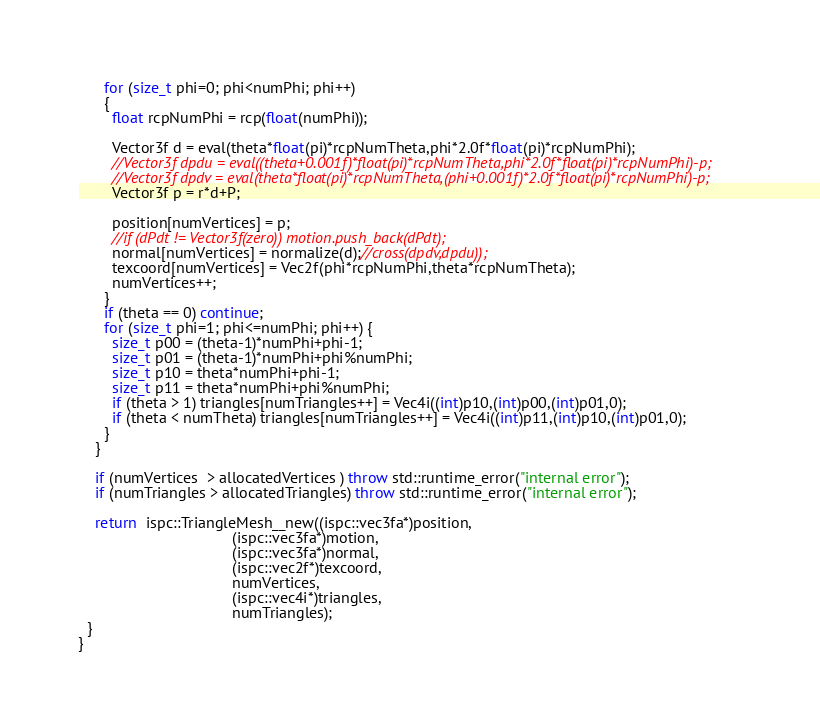Convert code to text. <code><loc_0><loc_0><loc_500><loc_500><_C++_>      for (size_t phi=0; phi<numPhi; phi++)
      {
        float rcpNumPhi = rcp(float(numPhi));
        
        Vector3f d = eval(theta*float(pi)*rcpNumTheta,phi*2.0f*float(pi)*rcpNumPhi);
        //Vector3f dpdu = eval((theta+0.001f)*float(pi)*rcpNumTheta,phi*2.0f*float(pi)*rcpNumPhi)-p;
        //Vector3f dpdv = eval(theta*float(pi)*rcpNumTheta,(phi+0.001f)*2.0f*float(pi)*rcpNumPhi)-p;
        Vector3f p = r*d+P;
        
        position[numVertices] = p;
        //if (dPdt != Vector3f(zero)) motion.push_back(dPdt);
        normal[numVertices] = normalize(d);//cross(dpdv,dpdu));
        texcoord[numVertices] = Vec2f(phi*rcpNumPhi,theta*rcpNumTheta);
        numVertices++;
      }
      if (theta == 0) continue;
      for (size_t phi=1; phi<=numPhi; phi++) {
        size_t p00 = (theta-1)*numPhi+phi-1;
        size_t p01 = (theta-1)*numPhi+phi%numPhi;
        size_t p10 = theta*numPhi+phi-1;
        size_t p11 = theta*numPhi+phi%numPhi;
        if (theta > 1) triangles[numTriangles++] = Vec4i((int)p10,(int)p00,(int)p01,0);
        if (theta < numTheta) triangles[numTriangles++] = Vec4i((int)p11,(int)p10,(int)p01,0);
      }
    }

    if (numVertices  > allocatedVertices ) throw std::runtime_error("internal error");
    if (numTriangles > allocatedTriangles) throw std::runtime_error("internal error");
    
    return  ispc::TriangleMesh__new((ispc::vec3fa*)position,
                                    (ispc::vec3fa*)motion,
                                    (ispc::vec3fa*)normal,
                                    (ispc::vec2f*)texcoord,
                                    numVertices,
                                    (ispc::vec4i*)triangles,
                                    numTriangles);
  }
}
</code> 